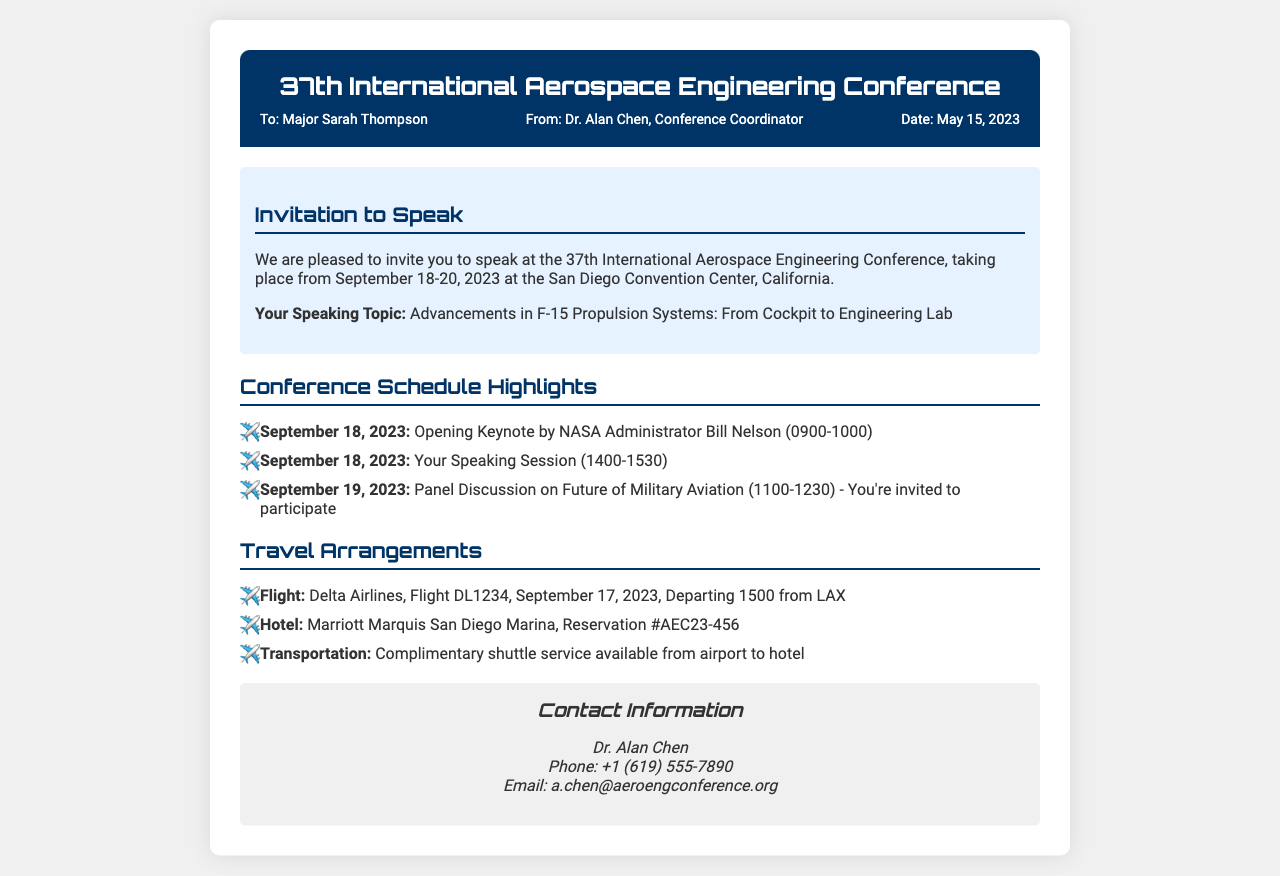What is the date of the conference? The conference takes place from September 18-20, 2023 as mentioned in the invitation.
Answer: September 18-20, 2023 Who is invited to speak? The document states Major Sarah Thompson is invited to speak at the conference.
Answer: Major Sarah Thompson What is the topic of your speaking session? The document specifies the topic as "Advancements in F-15 Propulsion Systems: From Cockpit to Engineering Lab."
Answer: Advancements in F-15 Propulsion Systems: From Cockpit to Engineering Lab When does your speaking session occur? The schedule indicates that the speaking session is on September 18, 2023, from 1400-1530.
Answer: September 18, 2023, 1400-1530 What is the flight number for your travel? The travel arrangements list the flight number as DL1234 for Delta Airlines.
Answer: DL1234 What is the name of the hotel listed? The document states that the hotel is the Marriott Marquis San Diego Marina.
Answer: Marriott Marquis San Diego Marina Who is the contact person for the conference? The contact information shows Dr. Alan Chen as the person to contact regarding the conference.
Answer: Dr. Alan Chen What type of transportation is offered from the airport? The document mentions complimentary shuttle service is available from the airport to the hotel.
Answer: Complimentary shuttle service 